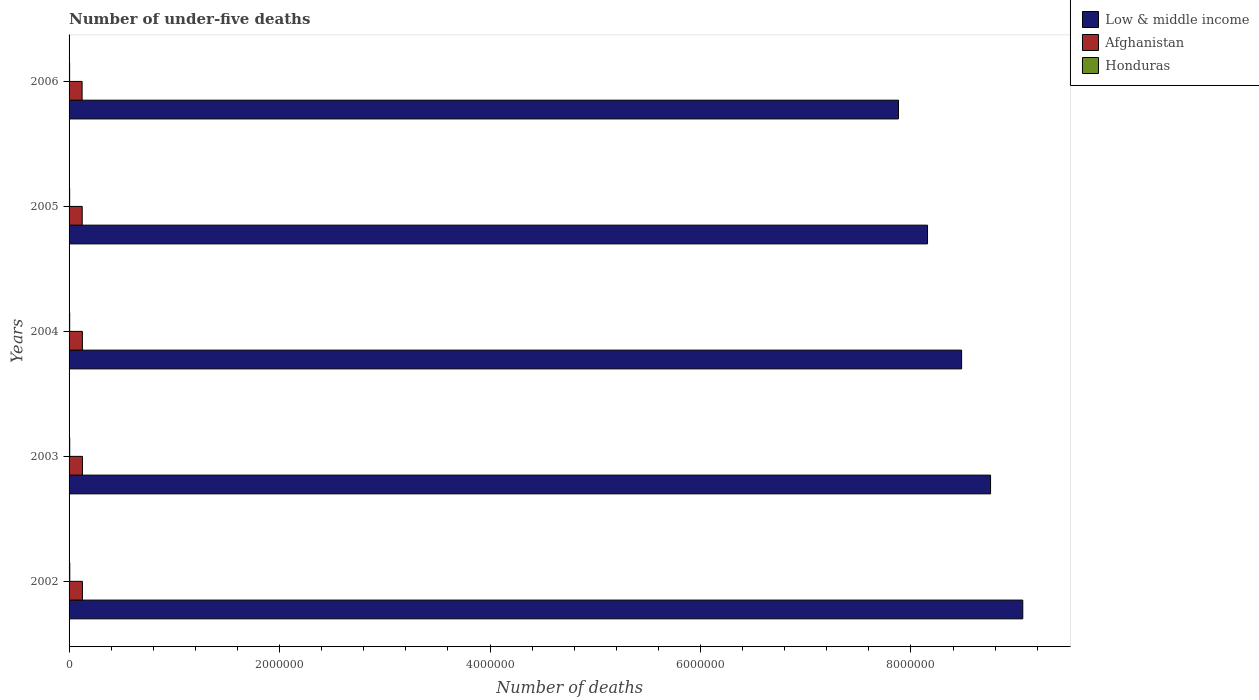How many different coloured bars are there?
Make the answer very short. 3. How many groups of bars are there?
Ensure brevity in your answer.  5. Are the number of bars per tick equal to the number of legend labels?
Your answer should be very brief. Yes. Are the number of bars on each tick of the Y-axis equal?
Your answer should be compact. Yes. How many bars are there on the 1st tick from the top?
Make the answer very short. 3. How many bars are there on the 5th tick from the bottom?
Keep it short and to the point. 3. What is the number of under-five deaths in Low & middle income in 2003?
Provide a short and direct response. 8.76e+06. Across all years, what is the maximum number of under-five deaths in Low & middle income?
Offer a terse response. 9.06e+06. Across all years, what is the minimum number of under-five deaths in Low & middle income?
Make the answer very short. 7.88e+06. In which year was the number of under-five deaths in Honduras minimum?
Your answer should be very brief. 2006. What is the total number of under-five deaths in Low & middle income in the graph?
Ensure brevity in your answer.  4.23e+07. What is the difference between the number of under-five deaths in Afghanistan in 2004 and that in 2005?
Provide a short and direct response. 1699. What is the difference between the number of under-five deaths in Honduras in 2003 and the number of under-five deaths in Low & middle income in 2002?
Your answer should be very brief. -9.06e+06. What is the average number of under-five deaths in Honduras per year?
Offer a very short reply. 5888.8. In the year 2006, what is the difference between the number of under-five deaths in Honduras and number of under-five deaths in Afghanistan?
Offer a terse response. -1.18e+05. What is the ratio of the number of under-five deaths in Low & middle income in 2003 to that in 2006?
Your answer should be compact. 1.11. Is the difference between the number of under-five deaths in Honduras in 2003 and 2004 greater than the difference between the number of under-five deaths in Afghanistan in 2003 and 2004?
Provide a succinct answer. No. What is the difference between the highest and the second highest number of under-five deaths in Honduras?
Provide a succinct answer. 370. What is the difference between the highest and the lowest number of under-five deaths in Afghanistan?
Your answer should be very brief. 3420. In how many years, is the number of under-five deaths in Honduras greater than the average number of under-five deaths in Honduras taken over all years?
Offer a terse response. 2. What does the 3rd bar from the top in 2006 represents?
Make the answer very short. Low & middle income. What does the 2nd bar from the bottom in 2002 represents?
Keep it short and to the point. Afghanistan. How many bars are there?
Keep it short and to the point. 15. Are all the bars in the graph horizontal?
Provide a short and direct response. Yes. How many years are there in the graph?
Keep it short and to the point. 5. Are the values on the major ticks of X-axis written in scientific E-notation?
Give a very brief answer. No. Does the graph contain grids?
Make the answer very short. No. How many legend labels are there?
Provide a short and direct response. 3. What is the title of the graph?
Give a very brief answer. Number of under-five deaths. Does "Zambia" appear as one of the legend labels in the graph?
Provide a short and direct response. No. What is the label or title of the X-axis?
Provide a succinct answer. Number of deaths. What is the Number of deaths in Low & middle income in 2002?
Make the answer very short. 9.06e+06. What is the Number of deaths in Afghanistan in 2002?
Give a very brief answer. 1.27e+05. What is the Number of deaths in Honduras in 2002?
Provide a short and direct response. 6569. What is the Number of deaths in Low & middle income in 2003?
Make the answer very short. 8.76e+06. What is the Number of deaths in Afghanistan in 2003?
Give a very brief answer. 1.27e+05. What is the Number of deaths in Honduras in 2003?
Make the answer very short. 6199. What is the Number of deaths in Low & middle income in 2004?
Offer a terse response. 8.48e+06. What is the Number of deaths of Afghanistan in 2004?
Offer a terse response. 1.26e+05. What is the Number of deaths in Honduras in 2004?
Give a very brief answer. 5858. What is the Number of deaths in Low & middle income in 2005?
Your answer should be very brief. 8.16e+06. What is the Number of deaths in Afghanistan in 2005?
Give a very brief answer. 1.25e+05. What is the Number of deaths of Honduras in 2005?
Your response must be concise. 5550. What is the Number of deaths in Low & middle income in 2006?
Ensure brevity in your answer.  7.88e+06. What is the Number of deaths in Afghanistan in 2006?
Offer a terse response. 1.24e+05. What is the Number of deaths of Honduras in 2006?
Ensure brevity in your answer.  5268. Across all years, what is the maximum Number of deaths in Low & middle income?
Provide a succinct answer. 9.06e+06. Across all years, what is the maximum Number of deaths of Afghanistan?
Your response must be concise. 1.27e+05. Across all years, what is the maximum Number of deaths of Honduras?
Provide a succinct answer. 6569. Across all years, what is the minimum Number of deaths of Low & middle income?
Offer a very short reply. 7.88e+06. Across all years, what is the minimum Number of deaths of Afghanistan?
Your response must be concise. 1.24e+05. Across all years, what is the minimum Number of deaths of Honduras?
Your answer should be very brief. 5268. What is the total Number of deaths in Low & middle income in the graph?
Offer a very short reply. 4.23e+07. What is the total Number of deaths of Afghanistan in the graph?
Keep it short and to the point. 6.29e+05. What is the total Number of deaths in Honduras in the graph?
Offer a very short reply. 2.94e+04. What is the difference between the Number of deaths in Low & middle income in 2002 and that in 2003?
Provide a succinct answer. 3.06e+05. What is the difference between the Number of deaths in Afghanistan in 2002 and that in 2003?
Keep it short and to the point. -251. What is the difference between the Number of deaths in Honduras in 2002 and that in 2003?
Your response must be concise. 370. What is the difference between the Number of deaths of Low & middle income in 2002 and that in 2004?
Provide a short and direct response. 5.81e+05. What is the difference between the Number of deaths in Afghanistan in 2002 and that in 2004?
Offer a terse response. 392. What is the difference between the Number of deaths of Honduras in 2002 and that in 2004?
Offer a terse response. 711. What is the difference between the Number of deaths of Low & middle income in 2002 and that in 2005?
Provide a short and direct response. 9.05e+05. What is the difference between the Number of deaths of Afghanistan in 2002 and that in 2005?
Your answer should be very brief. 2091. What is the difference between the Number of deaths in Honduras in 2002 and that in 2005?
Provide a short and direct response. 1019. What is the difference between the Number of deaths of Low & middle income in 2002 and that in 2006?
Provide a short and direct response. 1.18e+06. What is the difference between the Number of deaths of Afghanistan in 2002 and that in 2006?
Provide a short and direct response. 3169. What is the difference between the Number of deaths of Honduras in 2002 and that in 2006?
Your answer should be very brief. 1301. What is the difference between the Number of deaths in Low & middle income in 2003 and that in 2004?
Provide a short and direct response. 2.75e+05. What is the difference between the Number of deaths in Afghanistan in 2003 and that in 2004?
Make the answer very short. 643. What is the difference between the Number of deaths in Honduras in 2003 and that in 2004?
Give a very brief answer. 341. What is the difference between the Number of deaths in Low & middle income in 2003 and that in 2005?
Make the answer very short. 5.99e+05. What is the difference between the Number of deaths in Afghanistan in 2003 and that in 2005?
Give a very brief answer. 2342. What is the difference between the Number of deaths in Honduras in 2003 and that in 2005?
Offer a very short reply. 649. What is the difference between the Number of deaths of Low & middle income in 2003 and that in 2006?
Offer a very short reply. 8.75e+05. What is the difference between the Number of deaths of Afghanistan in 2003 and that in 2006?
Provide a succinct answer. 3420. What is the difference between the Number of deaths in Honduras in 2003 and that in 2006?
Offer a very short reply. 931. What is the difference between the Number of deaths in Low & middle income in 2004 and that in 2005?
Your answer should be compact. 3.24e+05. What is the difference between the Number of deaths of Afghanistan in 2004 and that in 2005?
Provide a succinct answer. 1699. What is the difference between the Number of deaths in Honduras in 2004 and that in 2005?
Ensure brevity in your answer.  308. What is the difference between the Number of deaths of Low & middle income in 2004 and that in 2006?
Your answer should be very brief. 6.00e+05. What is the difference between the Number of deaths in Afghanistan in 2004 and that in 2006?
Your response must be concise. 2777. What is the difference between the Number of deaths in Honduras in 2004 and that in 2006?
Your response must be concise. 590. What is the difference between the Number of deaths in Low & middle income in 2005 and that in 2006?
Provide a succinct answer. 2.76e+05. What is the difference between the Number of deaths of Afghanistan in 2005 and that in 2006?
Provide a succinct answer. 1078. What is the difference between the Number of deaths of Honduras in 2005 and that in 2006?
Provide a succinct answer. 282. What is the difference between the Number of deaths in Low & middle income in 2002 and the Number of deaths in Afghanistan in 2003?
Your answer should be very brief. 8.94e+06. What is the difference between the Number of deaths of Low & middle income in 2002 and the Number of deaths of Honduras in 2003?
Offer a very short reply. 9.06e+06. What is the difference between the Number of deaths in Afghanistan in 2002 and the Number of deaths in Honduras in 2003?
Offer a very short reply. 1.21e+05. What is the difference between the Number of deaths of Low & middle income in 2002 and the Number of deaths of Afghanistan in 2004?
Offer a very short reply. 8.94e+06. What is the difference between the Number of deaths of Low & middle income in 2002 and the Number of deaths of Honduras in 2004?
Your response must be concise. 9.06e+06. What is the difference between the Number of deaths in Afghanistan in 2002 and the Number of deaths in Honduras in 2004?
Give a very brief answer. 1.21e+05. What is the difference between the Number of deaths of Low & middle income in 2002 and the Number of deaths of Afghanistan in 2005?
Give a very brief answer. 8.94e+06. What is the difference between the Number of deaths in Low & middle income in 2002 and the Number of deaths in Honduras in 2005?
Provide a succinct answer. 9.06e+06. What is the difference between the Number of deaths of Afghanistan in 2002 and the Number of deaths of Honduras in 2005?
Offer a very short reply. 1.21e+05. What is the difference between the Number of deaths in Low & middle income in 2002 and the Number of deaths in Afghanistan in 2006?
Provide a succinct answer. 8.94e+06. What is the difference between the Number of deaths in Low & middle income in 2002 and the Number of deaths in Honduras in 2006?
Your answer should be compact. 9.06e+06. What is the difference between the Number of deaths of Afghanistan in 2002 and the Number of deaths of Honduras in 2006?
Make the answer very short. 1.22e+05. What is the difference between the Number of deaths of Low & middle income in 2003 and the Number of deaths of Afghanistan in 2004?
Your answer should be very brief. 8.63e+06. What is the difference between the Number of deaths of Low & middle income in 2003 and the Number of deaths of Honduras in 2004?
Give a very brief answer. 8.75e+06. What is the difference between the Number of deaths in Afghanistan in 2003 and the Number of deaths in Honduras in 2004?
Provide a short and direct response. 1.21e+05. What is the difference between the Number of deaths in Low & middle income in 2003 and the Number of deaths in Afghanistan in 2005?
Offer a very short reply. 8.63e+06. What is the difference between the Number of deaths in Low & middle income in 2003 and the Number of deaths in Honduras in 2005?
Provide a succinct answer. 8.75e+06. What is the difference between the Number of deaths in Afghanistan in 2003 and the Number of deaths in Honduras in 2005?
Your response must be concise. 1.22e+05. What is the difference between the Number of deaths of Low & middle income in 2003 and the Number of deaths of Afghanistan in 2006?
Offer a terse response. 8.63e+06. What is the difference between the Number of deaths in Low & middle income in 2003 and the Number of deaths in Honduras in 2006?
Give a very brief answer. 8.75e+06. What is the difference between the Number of deaths of Afghanistan in 2003 and the Number of deaths of Honduras in 2006?
Keep it short and to the point. 1.22e+05. What is the difference between the Number of deaths of Low & middle income in 2004 and the Number of deaths of Afghanistan in 2005?
Offer a terse response. 8.36e+06. What is the difference between the Number of deaths of Low & middle income in 2004 and the Number of deaths of Honduras in 2005?
Provide a short and direct response. 8.48e+06. What is the difference between the Number of deaths of Afghanistan in 2004 and the Number of deaths of Honduras in 2005?
Offer a terse response. 1.21e+05. What is the difference between the Number of deaths of Low & middle income in 2004 and the Number of deaths of Afghanistan in 2006?
Provide a short and direct response. 8.36e+06. What is the difference between the Number of deaths of Low & middle income in 2004 and the Number of deaths of Honduras in 2006?
Keep it short and to the point. 8.48e+06. What is the difference between the Number of deaths of Afghanistan in 2004 and the Number of deaths of Honduras in 2006?
Offer a terse response. 1.21e+05. What is the difference between the Number of deaths of Low & middle income in 2005 and the Number of deaths of Afghanistan in 2006?
Keep it short and to the point. 8.03e+06. What is the difference between the Number of deaths in Low & middle income in 2005 and the Number of deaths in Honduras in 2006?
Give a very brief answer. 8.15e+06. What is the difference between the Number of deaths of Afghanistan in 2005 and the Number of deaths of Honduras in 2006?
Your answer should be compact. 1.20e+05. What is the average Number of deaths of Low & middle income per year?
Provide a short and direct response. 8.47e+06. What is the average Number of deaths in Afghanistan per year?
Your answer should be very brief. 1.26e+05. What is the average Number of deaths of Honduras per year?
Offer a terse response. 5888.8. In the year 2002, what is the difference between the Number of deaths of Low & middle income and Number of deaths of Afghanistan?
Your answer should be compact. 8.94e+06. In the year 2002, what is the difference between the Number of deaths of Low & middle income and Number of deaths of Honduras?
Give a very brief answer. 9.06e+06. In the year 2002, what is the difference between the Number of deaths in Afghanistan and Number of deaths in Honduras?
Keep it short and to the point. 1.20e+05. In the year 2003, what is the difference between the Number of deaths of Low & middle income and Number of deaths of Afghanistan?
Keep it short and to the point. 8.63e+06. In the year 2003, what is the difference between the Number of deaths in Low & middle income and Number of deaths in Honduras?
Your answer should be compact. 8.75e+06. In the year 2003, what is the difference between the Number of deaths in Afghanistan and Number of deaths in Honduras?
Offer a very short reply. 1.21e+05. In the year 2004, what is the difference between the Number of deaths in Low & middle income and Number of deaths in Afghanistan?
Your answer should be very brief. 8.35e+06. In the year 2004, what is the difference between the Number of deaths in Low & middle income and Number of deaths in Honduras?
Provide a succinct answer. 8.48e+06. In the year 2004, what is the difference between the Number of deaths of Afghanistan and Number of deaths of Honduras?
Your answer should be very brief. 1.21e+05. In the year 2005, what is the difference between the Number of deaths in Low & middle income and Number of deaths in Afghanistan?
Your answer should be very brief. 8.03e+06. In the year 2005, what is the difference between the Number of deaths of Low & middle income and Number of deaths of Honduras?
Offer a terse response. 8.15e+06. In the year 2005, what is the difference between the Number of deaths in Afghanistan and Number of deaths in Honduras?
Offer a very short reply. 1.19e+05. In the year 2006, what is the difference between the Number of deaths in Low & middle income and Number of deaths in Afghanistan?
Your answer should be compact. 7.76e+06. In the year 2006, what is the difference between the Number of deaths in Low & middle income and Number of deaths in Honduras?
Offer a terse response. 7.88e+06. In the year 2006, what is the difference between the Number of deaths of Afghanistan and Number of deaths of Honduras?
Give a very brief answer. 1.18e+05. What is the ratio of the Number of deaths of Low & middle income in 2002 to that in 2003?
Your answer should be very brief. 1.03. What is the ratio of the Number of deaths of Honduras in 2002 to that in 2003?
Provide a succinct answer. 1.06. What is the ratio of the Number of deaths in Low & middle income in 2002 to that in 2004?
Your response must be concise. 1.07. What is the ratio of the Number of deaths in Honduras in 2002 to that in 2004?
Offer a very short reply. 1.12. What is the ratio of the Number of deaths of Low & middle income in 2002 to that in 2005?
Give a very brief answer. 1.11. What is the ratio of the Number of deaths of Afghanistan in 2002 to that in 2005?
Provide a short and direct response. 1.02. What is the ratio of the Number of deaths of Honduras in 2002 to that in 2005?
Make the answer very short. 1.18. What is the ratio of the Number of deaths in Low & middle income in 2002 to that in 2006?
Provide a succinct answer. 1.15. What is the ratio of the Number of deaths in Afghanistan in 2002 to that in 2006?
Your response must be concise. 1.03. What is the ratio of the Number of deaths of Honduras in 2002 to that in 2006?
Your answer should be very brief. 1.25. What is the ratio of the Number of deaths of Low & middle income in 2003 to that in 2004?
Offer a terse response. 1.03. What is the ratio of the Number of deaths in Afghanistan in 2003 to that in 2004?
Offer a terse response. 1.01. What is the ratio of the Number of deaths of Honduras in 2003 to that in 2004?
Your answer should be very brief. 1.06. What is the ratio of the Number of deaths of Low & middle income in 2003 to that in 2005?
Make the answer very short. 1.07. What is the ratio of the Number of deaths in Afghanistan in 2003 to that in 2005?
Provide a succinct answer. 1.02. What is the ratio of the Number of deaths of Honduras in 2003 to that in 2005?
Provide a short and direct response. 1.12. What is the ratio of the Number of deaths of Low & middle income in 2003 to that in 2006?
Make the answer very short. 1.11. What is the ratio of the Number of deaths of Afghanistan in 2003 to that in 2006?
Provide a short and direct response. 1.03. What is the ratio of the Number of deaths in Honduras in 2003 to that in 2006?
Ensure brevity in your answer.  1.18. What is the ratio of the Number of deaths in Low & middle income in 2004 to that in 2005?
Provide a short and direct response. 1.04. What is the ratio of the Number of deaths of Afghanistan in 2004 to that in 2005?
Give a very brief answer. 1.01. What is the ratio of the Number of deaths of Honduras in 2004 to that in 2005?
Give a very brief answer. 1.06. What is the ratio of the Number of deaths of Low & middle income in 2004 to that in 2006?
Give a very brief answer. 1.08. What is the ratio of the Number of deaths in Afghanistan in 2004 to that in 2006?
Make the answer very short. 1.02. What is the ratio of the Number of deaths in Honduras in 2004 to that in 2006?
Offer a very short reply. 1.11. What is the ratio of the Number of deaths in Low & middle income in 2005 to that in 2006?
Offer a very short reply. 1.03. What is the ratio of the Number of deaths in Afghanistan in 2005 to that in 2006?
Your answer should be very brief. 1.01. What is the ratio of the Number of deaths of Honduras in 2005 to that in 2006?
Give a very brief answer. 1.05. What is the difference between the highest and the second highest Number of deaths of Low & middle income?
Make the answer very short. 3.06e+05. What is the difference between the highest and the second highest Number of deaths of Afghanistan?
Make the answer very short. 251. What is the difference between the highest and the second highest Number of deaths of Honduras?
Ensure brevity in your answer.  370. What is the difference between the highest and the lowest Number of deaths in Low & middle income?
Your response must be concise. 1.18e+06. What is the difference between the highest and the lowest Number of deaths of Afghanistan?
Provide a short and direct response. 3420. What is the difference between the highest and the lowest Number of deaths of Honduras?
Keep it short and to the point. 1301. 